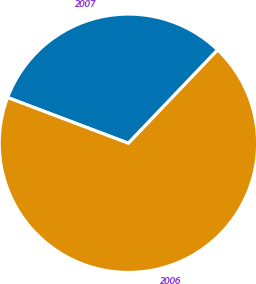<chart> <loc_0><loc_0><loc_500><loc_500><pie_chart><fcel>2007<fcel>2006<nl><fcel>31.38%<fcel>68.62%<nl></chart> 